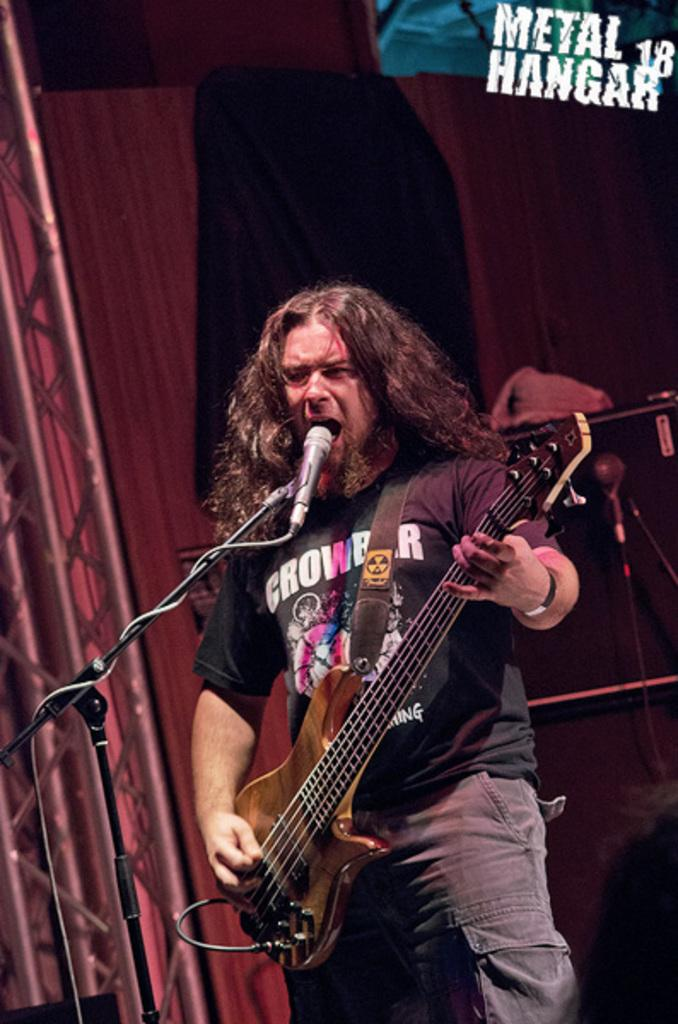What is the man in the image doing? The man is holding a guitar and singing into a microphone. What object is the man holding in the image? The man is holding a guitar. What can be seen in the background of the image? There is a wooden door and a curtain in the background of the image. How many jellyfish are swimming in the background of the image? There are no jellyfish present in the image; it features a man holding a guitar and singing into a microphone, with a wooden door and curtain in the background. 